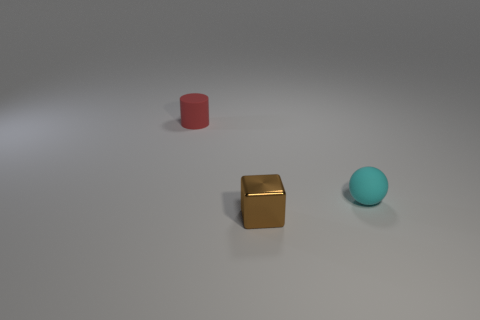Add 3 tiny shiny cubes. How many objects exist? 6 Subtract all spheres. How many objects are left? 2 Add 2 small brown shiny cubes. How many small brown shiny cubes are left? 3 Add 1 tiny cyan rubber balls. How many tiny cyan rubber balls exist? 2 Subtract 0 purple blocks. How many objects are left? 3 Subtract all metallic objects. Subtract all small cyan spheres. How many objects are left? 1 